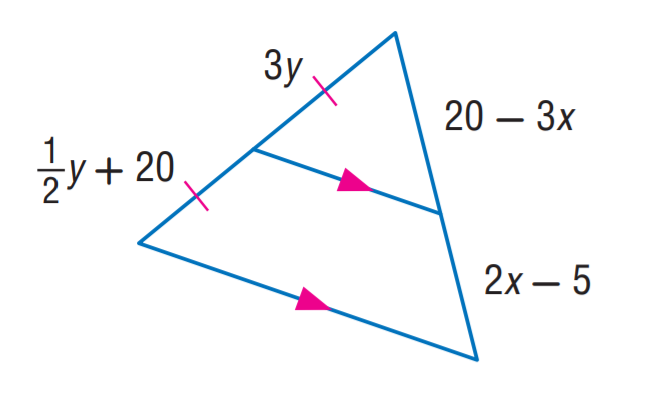Question: Find x.
Choices:
A. 3
B. 5
C. 6
D. 8
Answer with the letter. Answer: B Question: Find y.
Choices:
A. 6
B. 8
C. 10
D. 20
Answer with the letter. Answer: B 